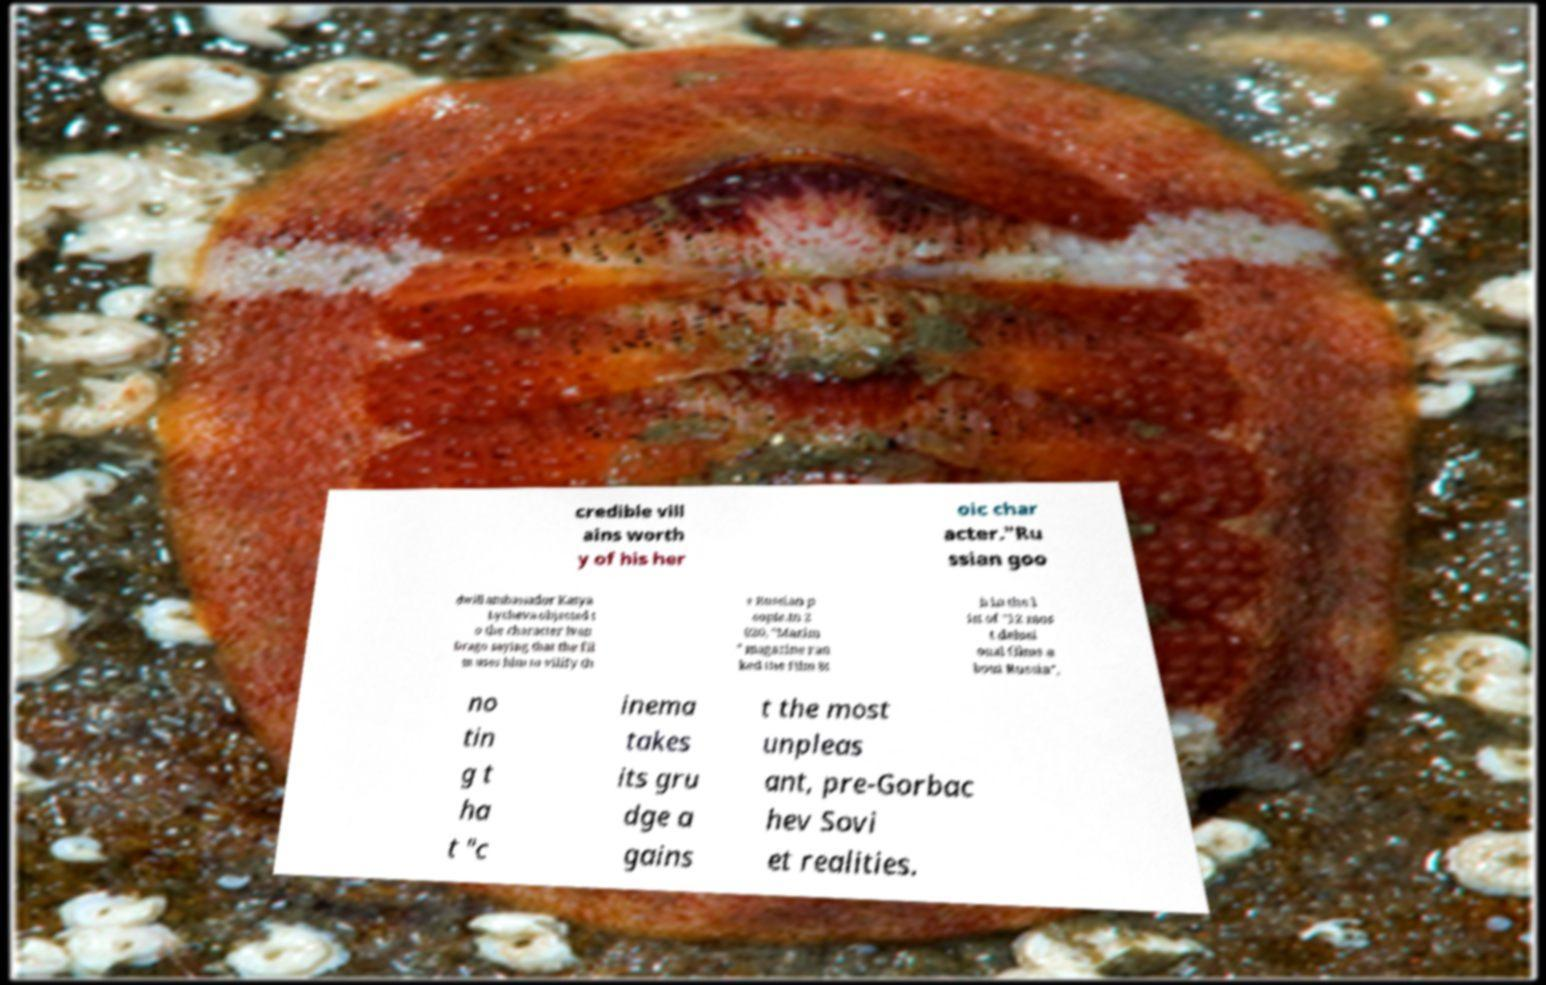Could you assist in decoding the text presented in this image and type it out clearly? credible vill ains worth y of his her oic char acter."Ru ssian goo dwill ambassador Katya Lycheva objected t o the character Ivan Drago saying that the fil m uses him to vilify th e Russian p eople.In 2 020, "Maxim " magazine ran ked the film 8t h in the l ist of "12 mos t delusi onal films a bout Russia", no tin g t ha t "c inema takes its gru dge a gains t the most unpleas ant, pre-Gorbac hev Sovi et realities. 